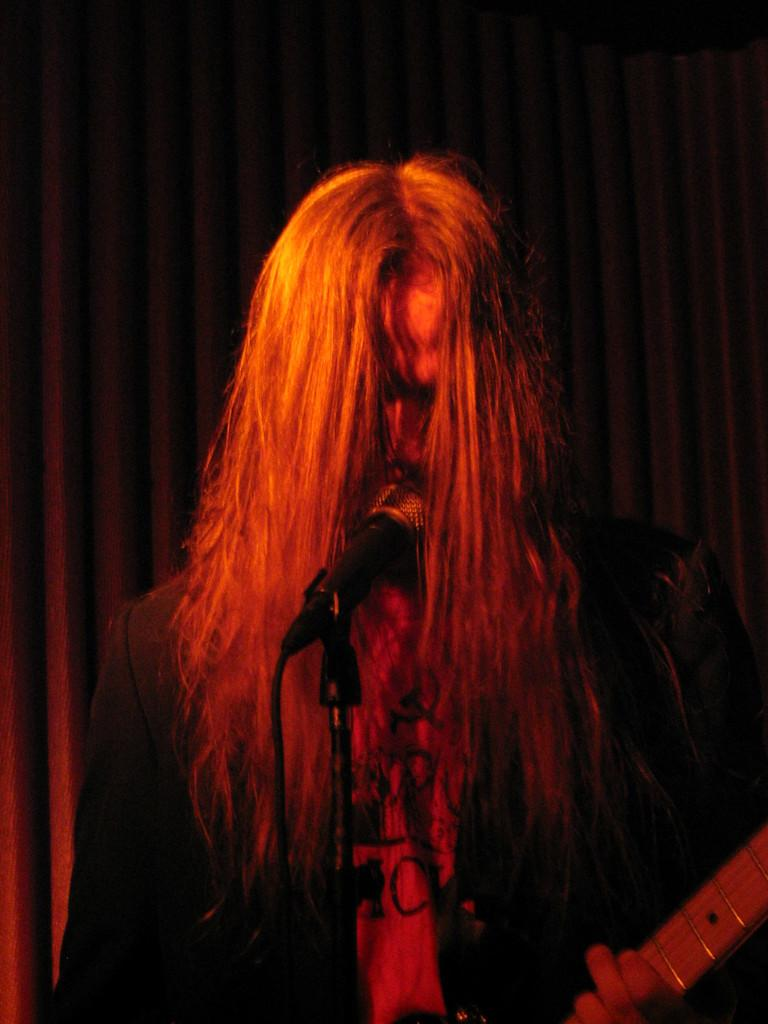What is the main subject of the image? There is a person in the image. What is the person doing in the image? The person is standing in front of a mic. What object is the person holding in the image? The person is holding a guitar. What type of vegetable is being ordered by the person in the image? There is no vegetable or order present in the image; the person is holding a guitar and standing in front of a mic. 